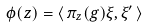Convert formula to latex. <formula><loc_0><loc_0><loc_500><loc_500>\phi ( z ) = \langle \, \pi _ { z } ( g ) \xi , \xi ^ { \prime } \, \rangle</formula> 